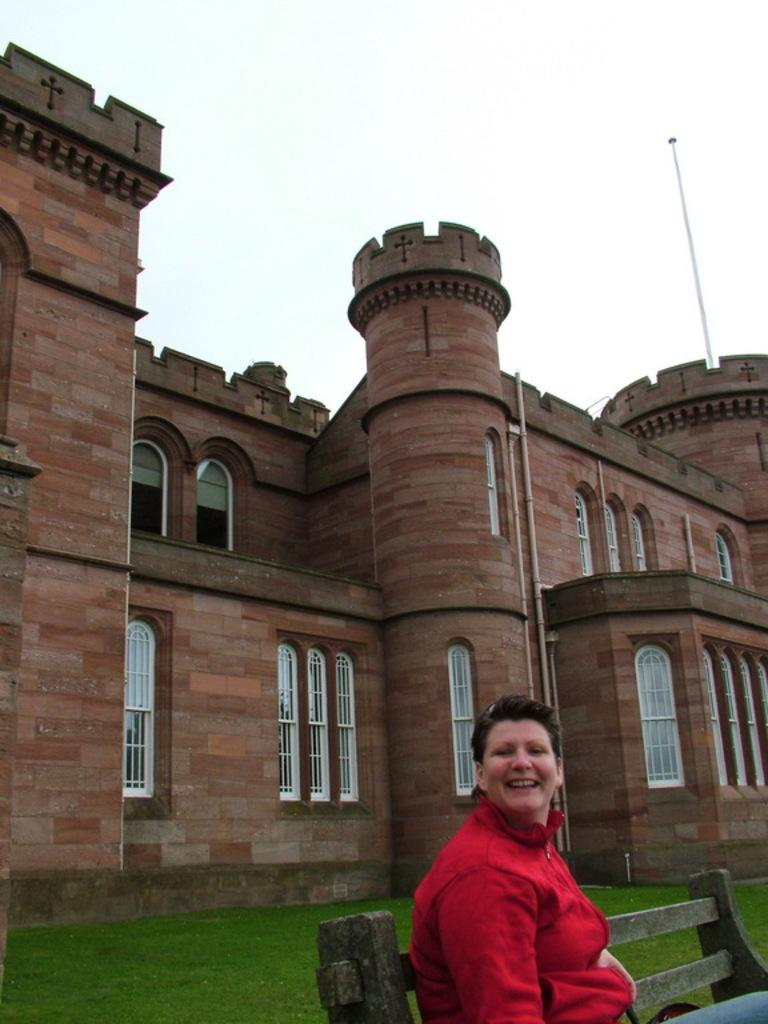What is the person in the image doing? There is a person sitting on a bench in the image. What can be seen behind the person? There is a building and grass visible in the background of the image. What is visible above the building and grass? The sky is visible in the background of the image. What thoughts are going through the person's mind in the image? There is no way to determine the person's thoughts from the image alone. --- Facts: 1. There is a car in the image. 2. The car is red. 3. The car has four wheels. 4. There is a road in the image. 5. The road is paved. Absurd Topics: ocean, parrot, dance Conversation: What is the main subject of the image? There is a car in the image. What color is the car? The car is red. How many wheels does the car have? The car has four wheels. What can be seen in the background of the image? There is a road in the image. What is the surface of the road like? The road is paved. Reasoning: Let's think step by step in order to produce the conversation. We start by identifying the main subject in the image, which is the car. Then, we expand the conversation to include other details about the car, such as its color and the number of wheels. Next, we describe the background of the image, which includes a road. Finally, we provide information about the road's surface, which is paved. Absurd Question/Answer: Can you see any parrots flying over the ocean in the image? There is no ocean or parrots present in the image; it features a red car with four wheels and a paved road in the background. 